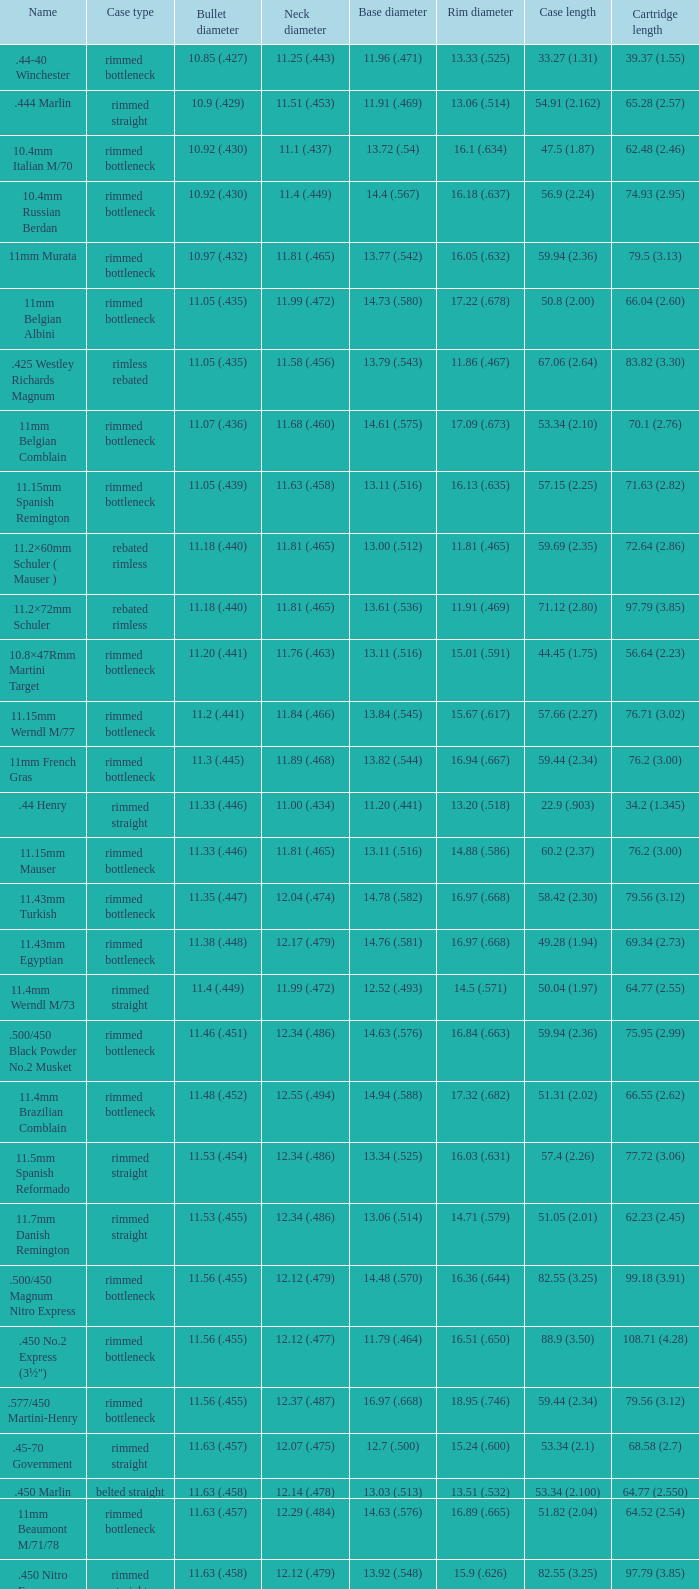Which bullet caliber has a neck dimension of 1 11.38 (.448). 